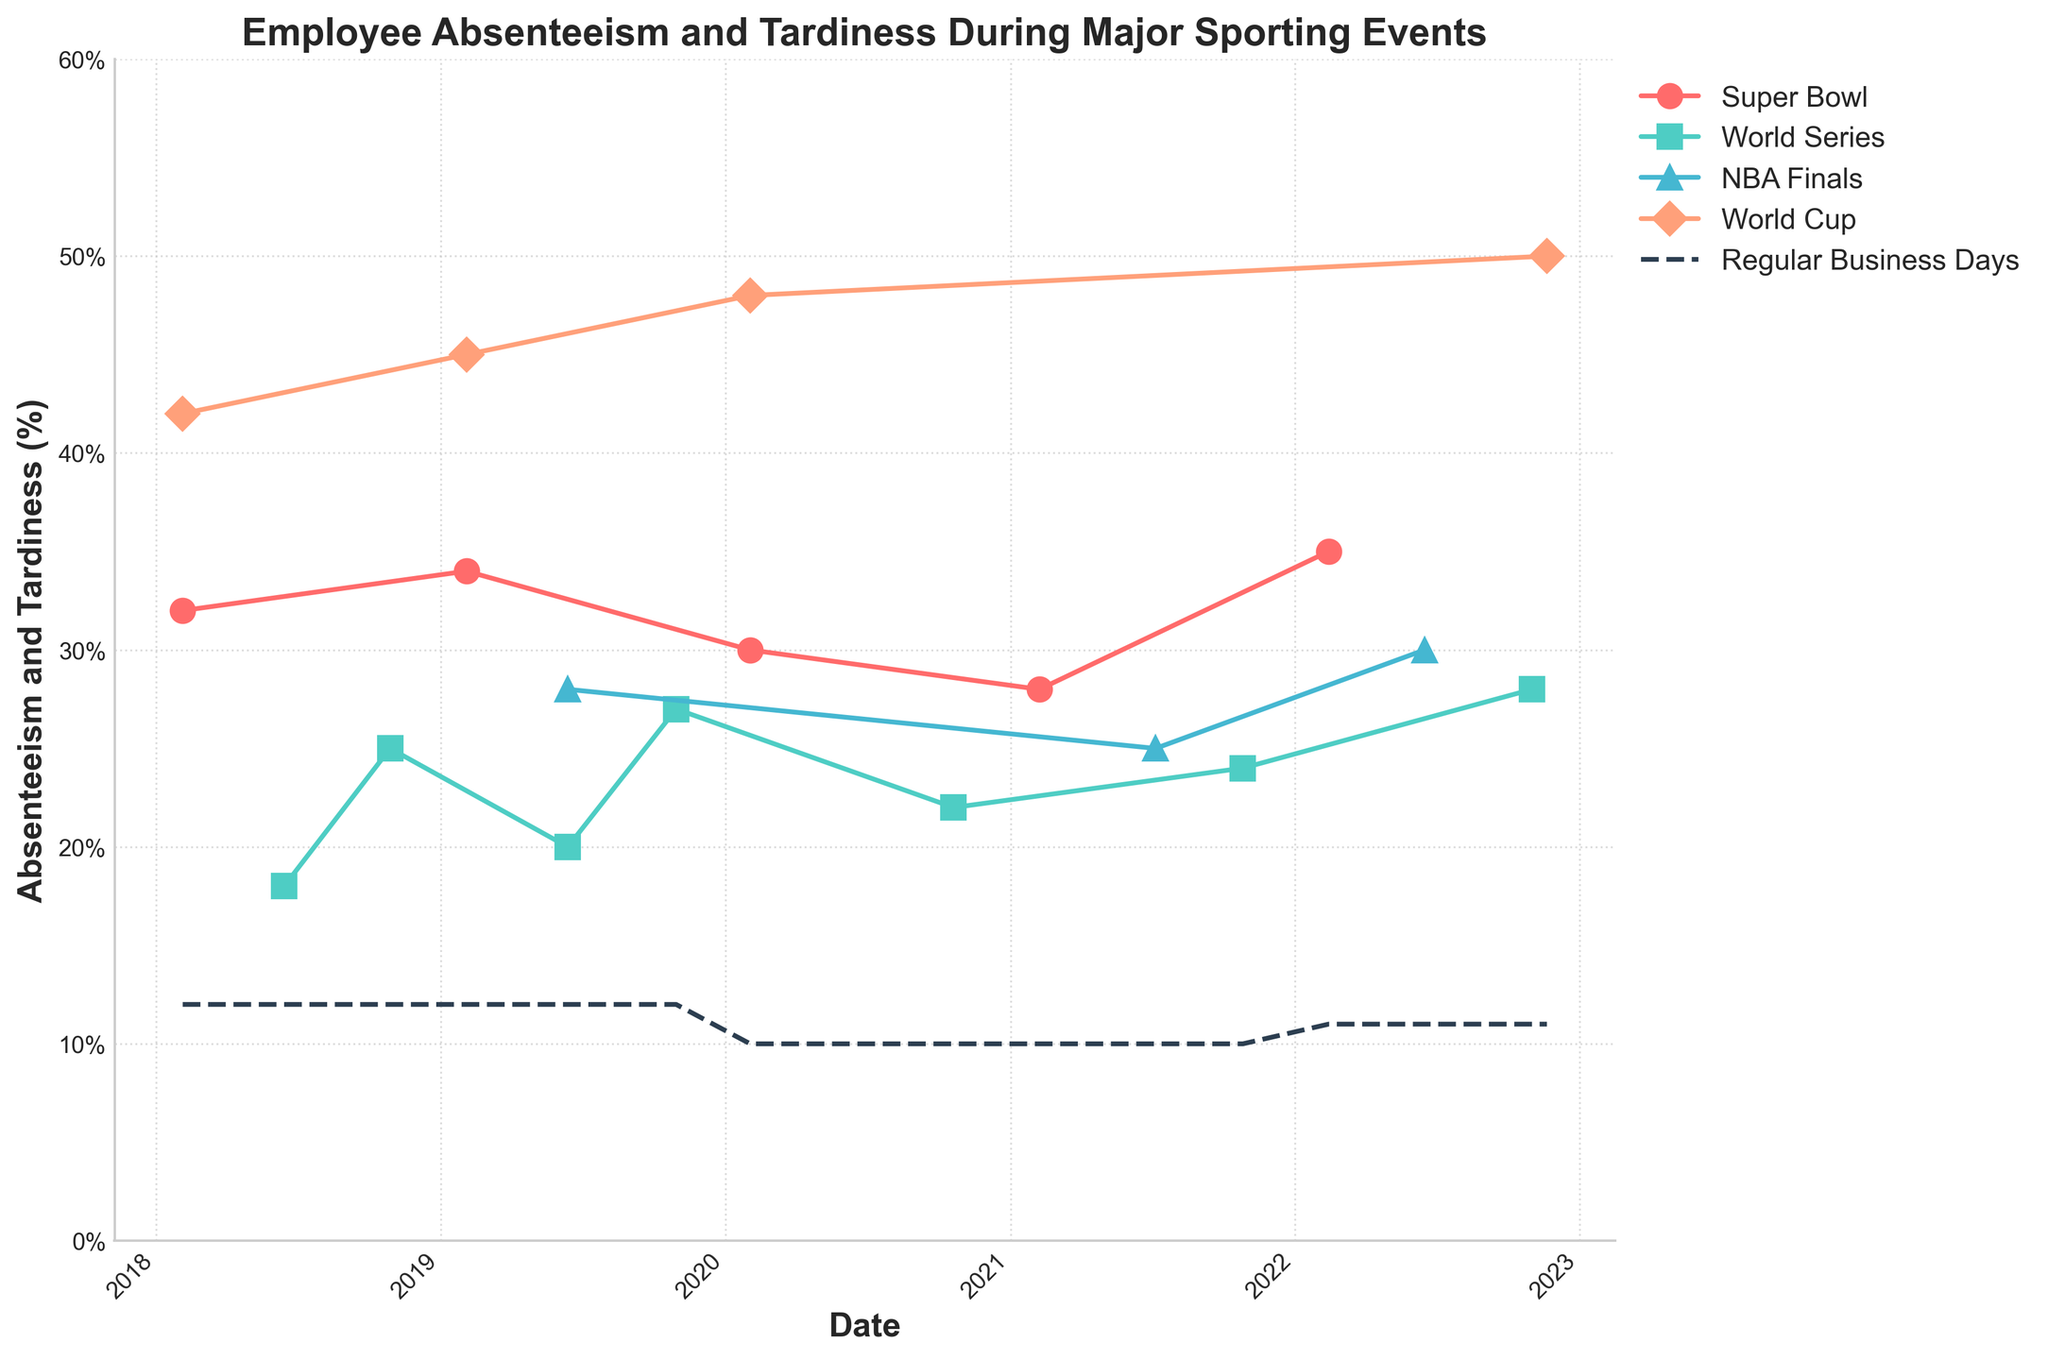What's the trend in absenteeism and tardiness on days with the Super Bowl over the years? By looking at the line representing the Super Bowl, it is noticeable that the percentage of absenteeism and tardiness slightly fluctuated but generally remained high. Specifically, it started at 32% in 2018, peaked at 35% in 2022, mostly staying above 30% throughout the years.
Answer: The trend has remained high, mostly above 30% On which day did the World Cup have the highest absenteeism and tardiness percentage? Inspecting the line representing the World Cup, the highest percentage is observed on the date 2022-11-20 with an absenteeism and tardiness rate of 50%.
Answer: 2022-11-20 How does the percentage of absenteeism and tardiness during the NBA Finals in 2022 compare to the regular business days? For the NBA Finals in 2022, the percentage is 30%, and for regular business days during the same year, it is 11%.
Answer: Higher on NBA Finals days Which event caused the most significant increase in absenteeism and tardiness compared to regular business days on its highest recorded day? The World Cup on 2022-11-20 had the highest increase, with a rate of 50% compared to regular business days at 11% (a difference of 39%).
Answer: World Cup on 2022-11-20 What is the average absenteeism and tardiness percentage for the Super Bowl from 2018 to 2022? Add percentages: (32% + 34% + 30% + 28% + 35%) = 159%, divide by 5 years: 159% / 5.
Answer: 31.8% Which had more variability in absenteeism and tardiness, the NBA Finals or the World Series? Compare the fluctuations of each event's lines. The NBA Finals line varies from 25% to 30% whereas the World Series varies from 18% to 28%. The World Series shows more variability.
Answer: The World Series Is there any noticeable yearly trend in absenteeism and tardiness for regular business days? Inspecting the 'Regular Business Days' line, it remains relatively stable, between 10% and 12% over the years.
Answer: No noticeable yearly trend What can be inferred about the impact of major sporting events on absenteeism and tardiness in comparison to regular days? By comparing the line for regular business days (10-12%) to those of major sporting events (often 18-50%), it's evident that major sporting events significantly increase absenteeism and tardiness percentages.
Answer: Major sporting events significantly increase absenteeism and tardiness Which event in 2019 had the highest percentage of absenteeism and tardiness? Look at the year 2019 data: Super Bowl (34%), NBA Finals (28%), World Series (25%). The Super Bowl has the highest percentage.
Answer: Super Bowl 